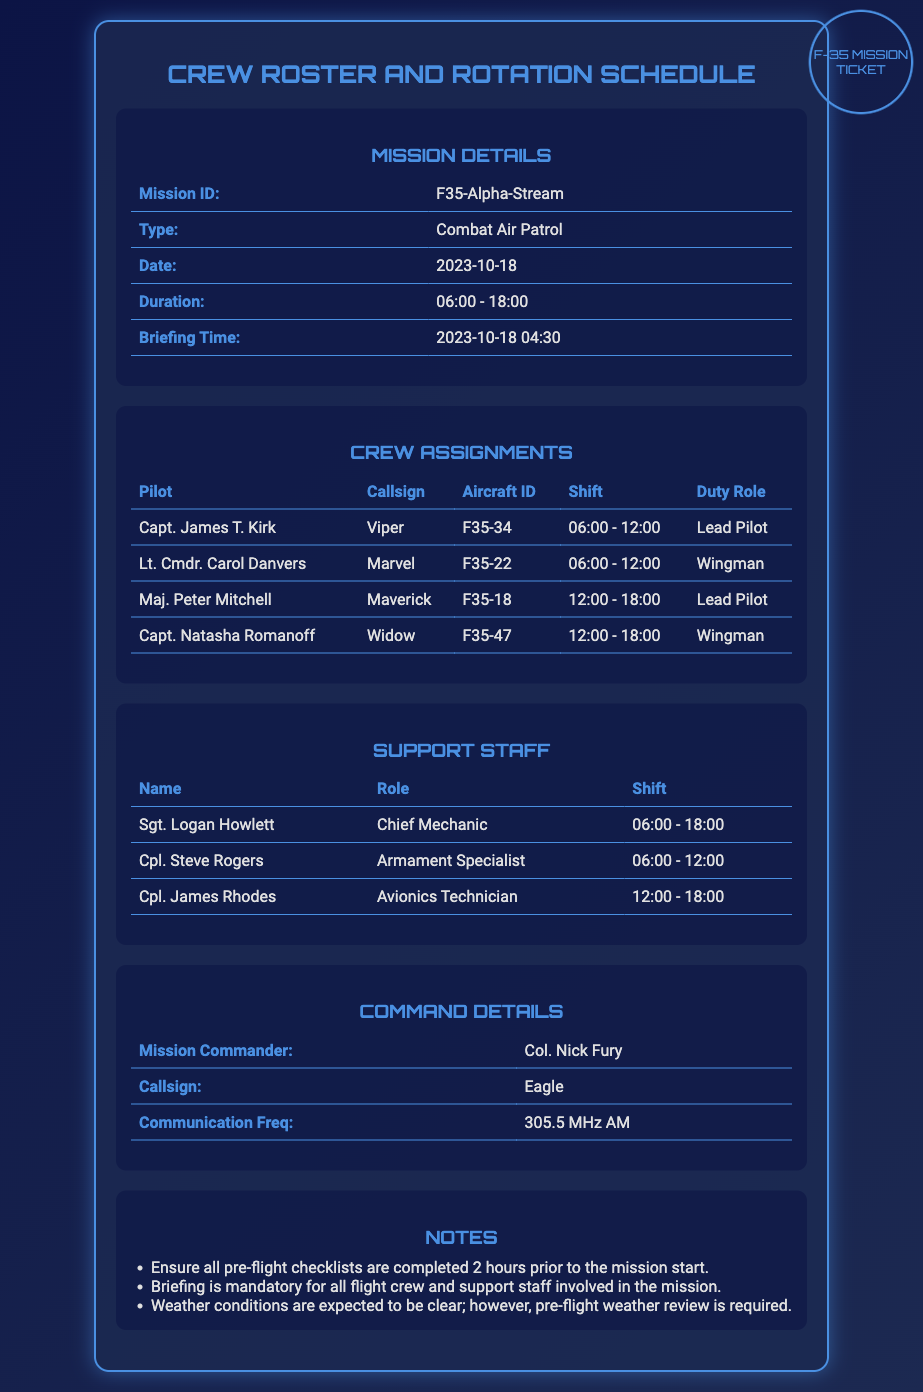What is the mission ID? The mission ID is found in the mission details section of the document.
Answer: F35-Alpha-Stream What is Capt. James T. Kirk's callsign? The callsign for Capt. James T. Kirk is listed in the crew assignments section.
Answer: Viper What time does the briefing start? The briefing time is mentioned in the mission details section.
Answer: 04:30 Who is the mission commander? The mission commander is specified in the command details section.
Answer: Col. Nick Fury Which aircraft is Lt. Cmdr. Carol Danvers assigned to? The aircraft ID for Lt. Cmdr. Carol Danvers is provided in the crew assignments table.
Answer: F35-22 What are the shift times for the Chief Mechanic? The shift time for the Chief Mechanic is found in the support staff section.
Answer: 06:00 - 18:00 How many Lead Pilots are assigned to the mission? The number of Lead Pilots is determined by counting the roles in the crew assignments section.
Answer: 2 What is the communication frequency for the mission? The communication frequency is specified in the command details section.
Answer: 305.5 MHz AM What is the expected weather condition for the mission? The expectation regarding weather conditions is stated in the notes section.
Answer: Clear 